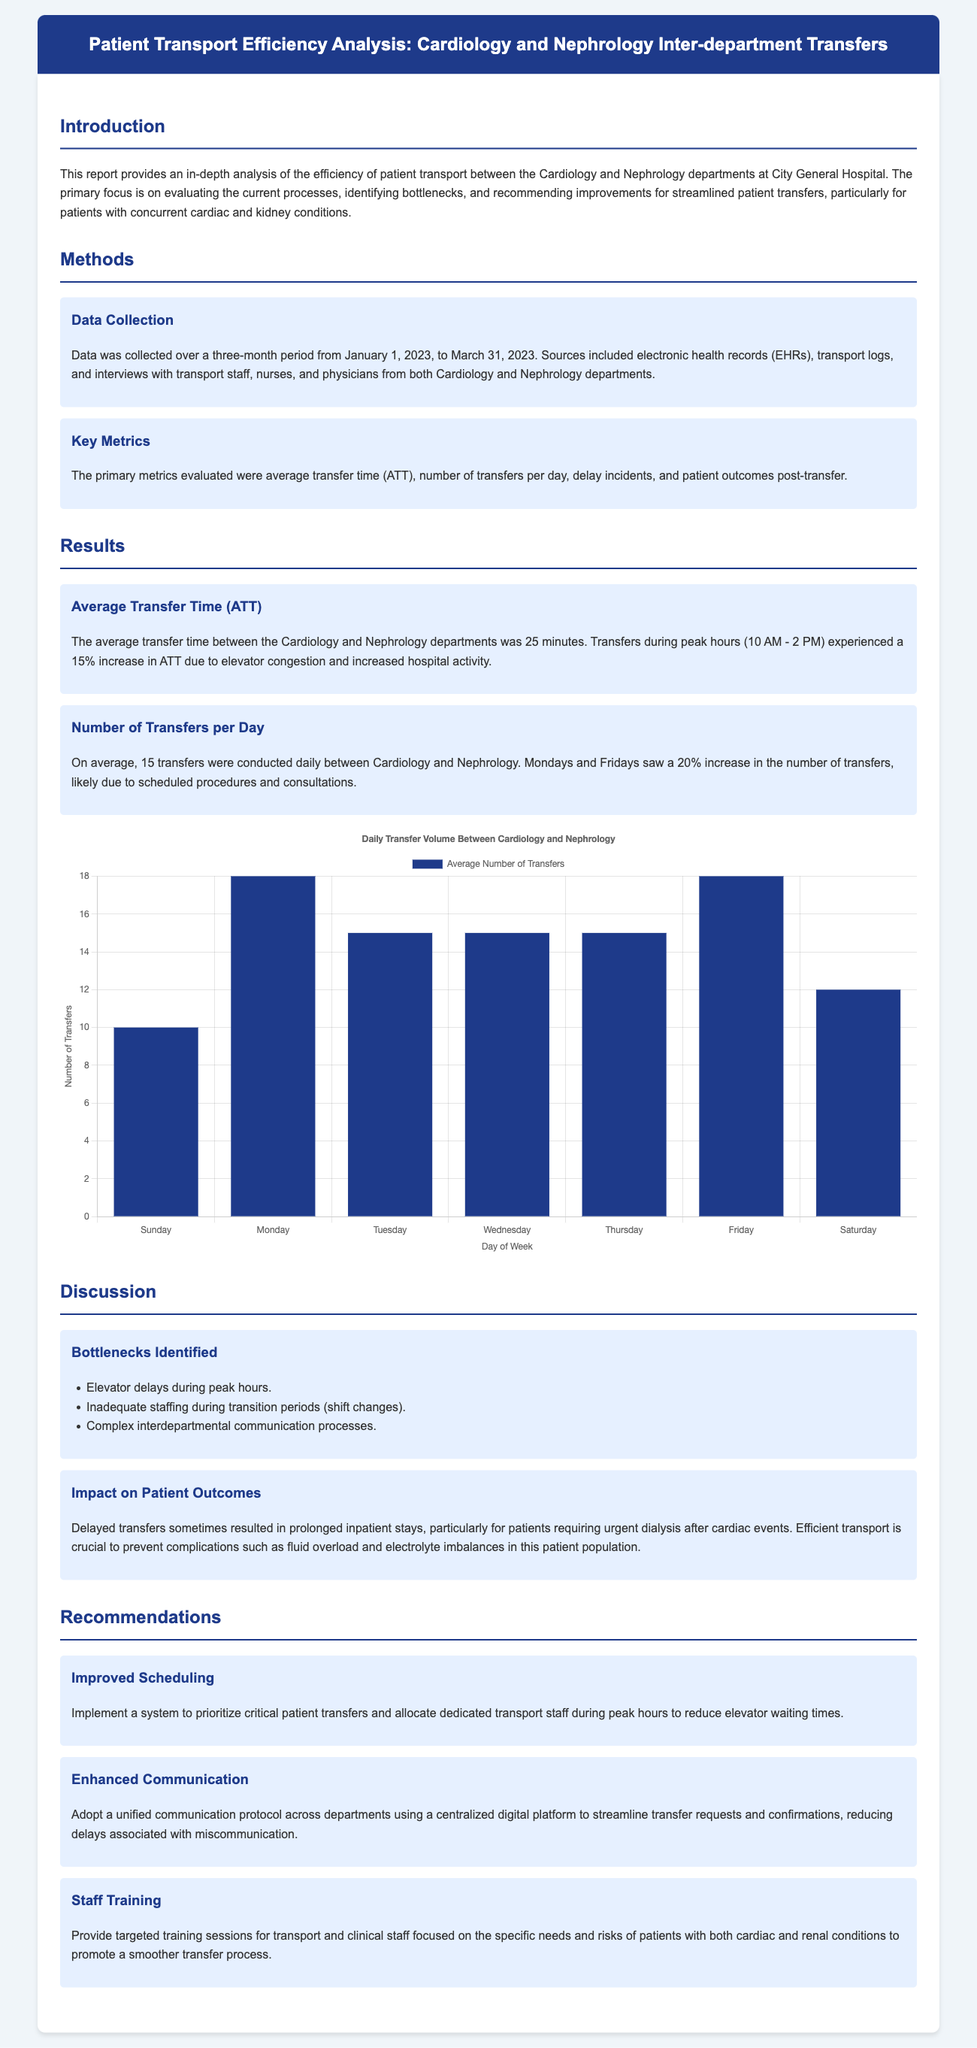what is the average transfer time between the departments? The average transfer time is given as 25 minutes in the results section of the document.
Answer: 25 minutes what was the date range for data collection? The document specifies the data was collected from January 1, 2023, to March 31, 2023.
Answer: January 1, 2023, to March 31, 2023 how many transfers were conducted daily on average? The daily average number of transfers is mentioned in the results section as 15 transfers per day.
Answer: 15 transfers what percentage increase in average transfer time occurs during peak hours? The document states there is a 15% increase in average transfer time during peak hours due to elevator congestion.
Answer: 15% which days saw a 20% increase in transfers? The report indicates that Mondays and Fridays experienced this increase likely due to scheduled procedures.
Answer: Mondays and Fridays what is one identified bottleneck during patient transfers? The document lists elevator delays during peak hours as one of the bottlenecks that hinder efficient patient transfer.
Answer: Elevator delays what is one recommendation for improving patient transport? The report suggests implementing a system to prioritize critical patient transfers as one of the recommendations.
Answer: Improved Scheduling how many total days of data were collected over the three-month period? The period from January 1 to March 31 includes exactly 90 days.
Answer: 90 days 